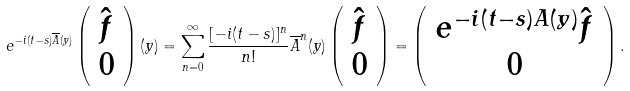<formula> <loc_0><loc_0><loc_500><loc_500>e ^ { - i ( t - s ) \overline { A } ( y ) } \left ( \begin{array} { c } \hat { f } \\ 0 \end{array} \right ) ( y ) = \sum _ { n = 0 } ^ { \infty } \frac { [ - i ( t - s ) ] ^ { n } } { n ! } \overline { A } ^ { n } ( y ) \left ( \begin{array} { c } \hat { f } \\ 0 \end{array} \right ) = \left ( \begin{array} { c } e ^ { - i ( t - s ) A ( y ) } \hat { f } \\ 0 \end{array} \right ) .</formula> 